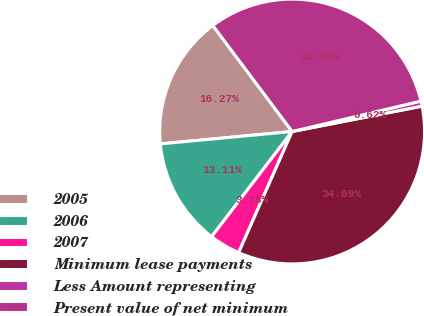<chart> <loc_0><loc_0><loc_500><loc_500><pie_chart><fcel>2005<fcel>2006<fcel>2007<fcel>Minimum lease payments<fcel>Less Amount representing<fcel>Present value of net minimum<nl><fcel>16.27%<fcel>13.11%<fcel>3.78%<fcel>34.69%<fcel>0.62%<fcel>31.53%<nl></chart> 